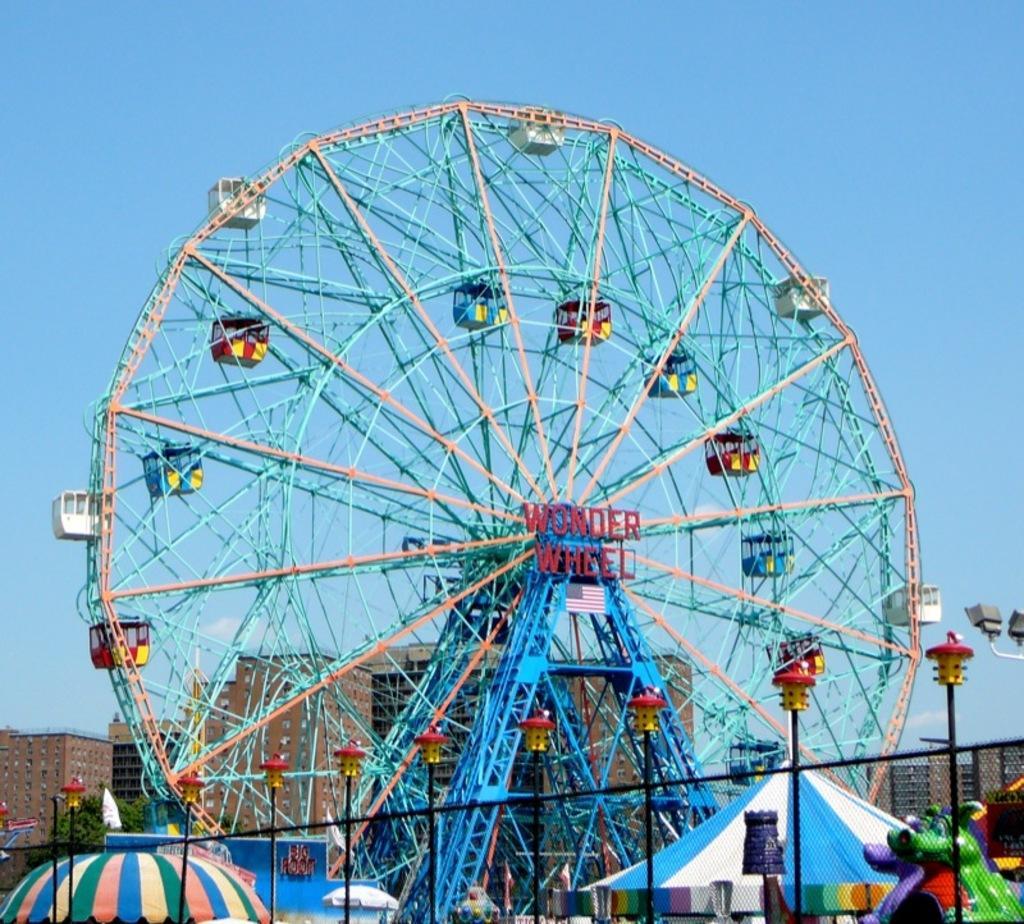In one or two sentences, can you explain what this image depicts? In this image, I can see a giant wheel with the cabins. This is a name board attached to a giant wheel. I can see the tents. At the bottom of the image, these look like the iron grilles and the toys. In the background, I can see the buildings. This is the sky. 